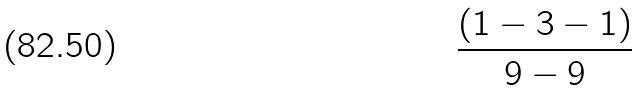Convert formula to latex. <formula><loc_0><loc_0><loc_500><loc_500>\frac { ( 1 - 3 - 1 ) } { 9 - 9 }</formula> 